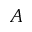<formula> <loc_0><loc_0><loc_500><loc_500>A</formula> 